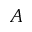<formula> <loc_0><loc_0><loc_500><loc_500>A</formula> 